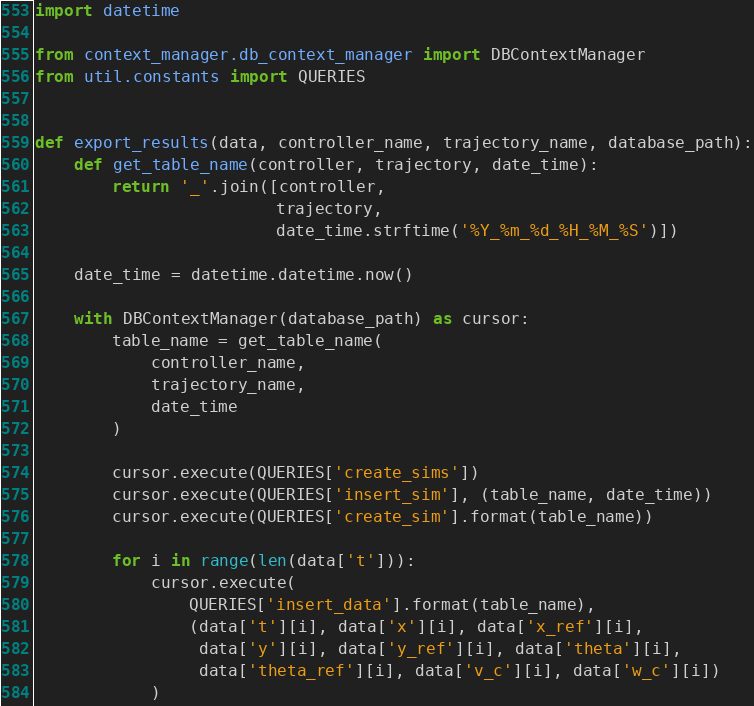<code> <loc_0><loc_0><loc_500><loc_500><_Python_>import datetime

from context_manager.db_context_manager import DBContextManager
from util.constants import QUERIES


def export_results(data, controller_name, trajectory_name, database_path):
    def get_table_name(controller, trajectory, date_time):
        return '_'.join([controller,
                         trajectory,
                         date_time.strftime('%Y_%m_%d_%H_%M_%S')])

    date_time = datetime.datetime.now()

    with DBContextManager(database_path) as cursor:
        table_name = get_table_name(
            controller_name,
            trajectory_name,
            date_time
        )

        cursor.execute(QUERIES['create_sims'])
        cursor.execute(QUERIES['insert_sim'], (table_name, date_time))
        cursor.execute(QUERIES['create_sim'].format(table_name))

        for i in range(len(data['t'])):
            cursor.execute(
                QUERIES['insert_data'].format(table_name),
                (data['t'][i], data['x'][i], data['x_ref'][i],
                 data['y'][i], data['y_ref'][i], data['theta'][i],
                 data['theta_ref'][i], data['v_c'][i], data['w_c'][i])
            )
</code> 